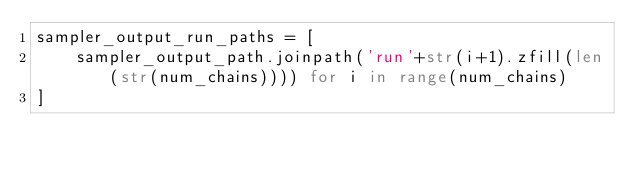<code> <loc_0><loc_0><loc_500><loc_500><_Python_>sampler_output_run_paths = [
    sampler_output_path.joinpath('run'+str(i+1).zfill(len(str(num_chains)))) for i in range(num_chains)
]
</code> 